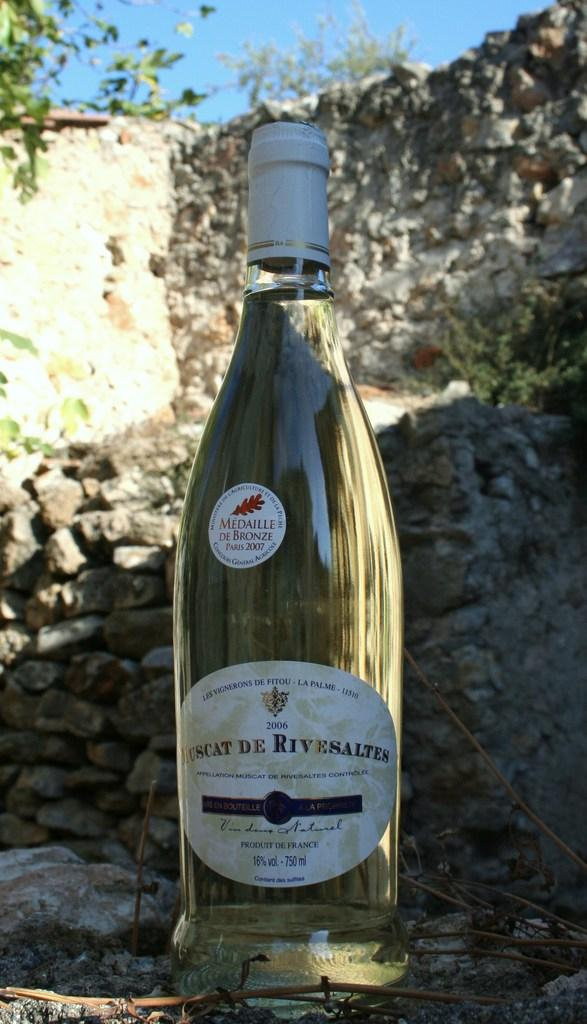Provide a one-sentence caption for the provided image. Large bottle that says the year 2007 on the top. 